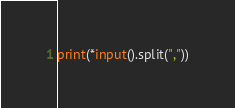<code> <loc_0><loc_0><loc_500><loc_500><_Python_>print(*input().split(","))</code> 